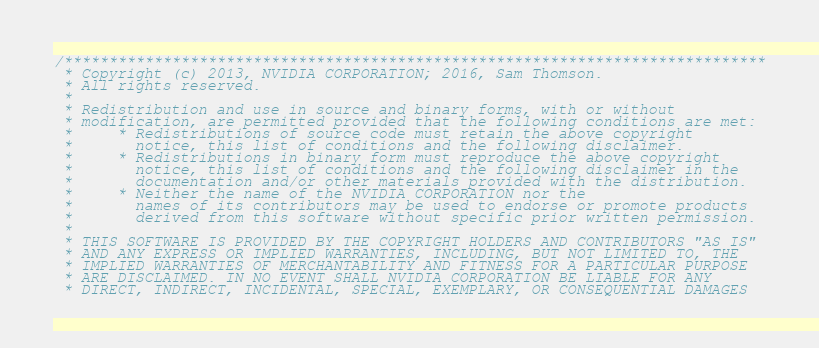Convert code to text. <code><loc_0><loc_0><loc_500><loc_500><_Cuda_>/******************************************************************************
 * Copyright (c) 2013, NVIDIA CORPORATION; 2016, Sam Thomson.
 * All rights reserved.
 *
 * Redistribution and use in source and binary forms, with or without
 * modification, are permitted provided that the following conditions are met:
 *     * Redistributions of source code must retain the above copyright
 *       notice, this list of conditions and the following disclaimer.
 *     * Redistributions in binary form must reproduce the above copyright
 *       notice, this list of conditions and the following disclaimer in the
 *       documentation and/or other materials provided with the distribution.
 *     * Neither the name of the NVIDIA CORPORATION nor the
 *       names of its contributors may be used to endorse or promote products
 *       derived from this software without specific prior written permission.
 *
 * THIS SOFTWARE IS PROVIDED BY THE COPYRIGHT HOLDERS AND CONTRIBUTORS "AS IS"
 * AND ANY EXPRESS OR IMPLIED WARRANTIES, INCLUDING, BUT NOT LIMITED TO, THE
 * IMPLIED WARRANTIES OF MERCHANTABILITY AND FITNESS FOR A PARTICULAR PURPOSE
 * ARE DISCLAIMED. IN NO EVENT SHALL NVIDIA CORPORATION BE LIABLE FOR ANY
 * DIRECT, INDIRECT, INCIDENTAL, SPECIAL, EXEMPLARY, OR CONSEQUENTIAL DAMAGES</code> 